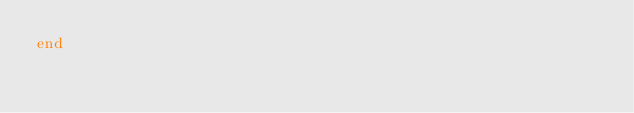<code> <loc_0><loc_0><loc_500><loc_500><_Ruby_>end
</code> 